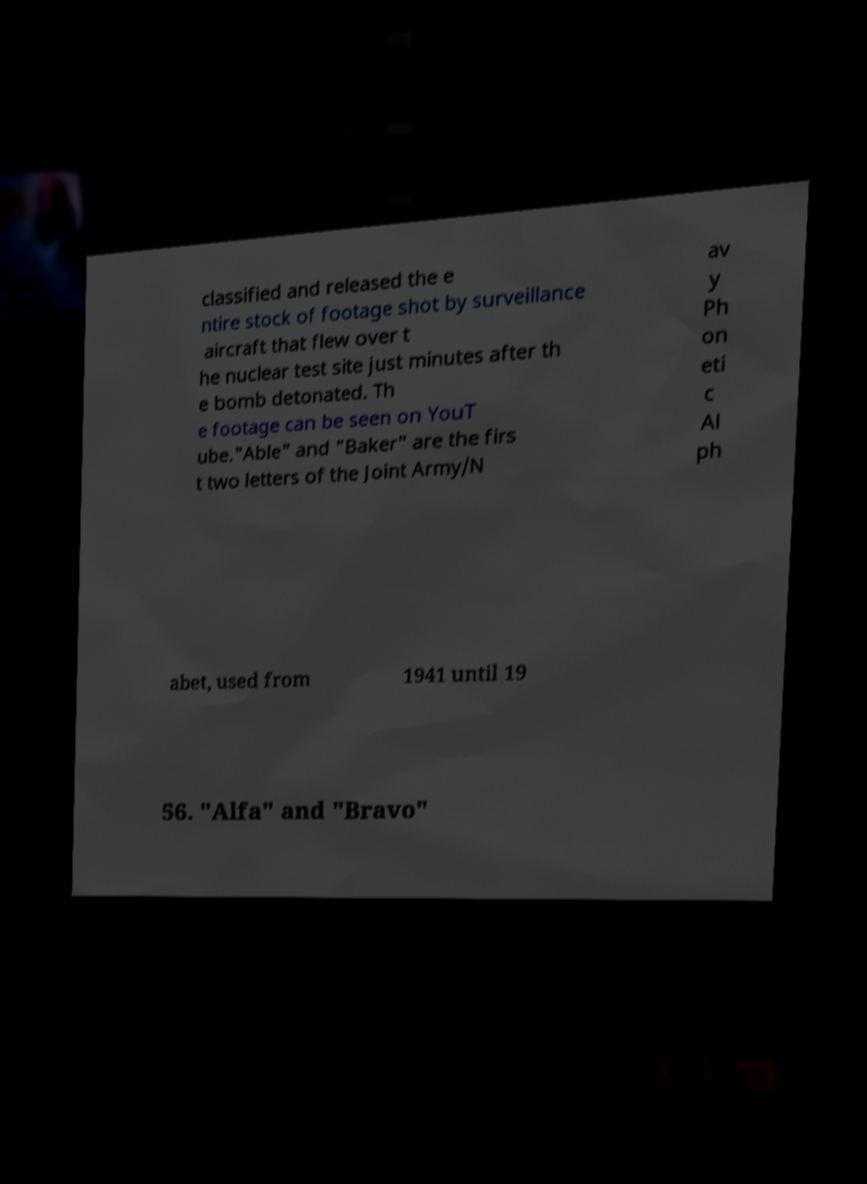What messages or text are displayed in this image? I need them in a readable, typed format. classified and released the e ntire stock of footage shot by surveillance aircraft that flew over t he nuclear test site just minutes after th e bomb detonated. Th e footage can be seen on YouT ube."Able" and "Baker" are the firs t two letters of the Joint Army/N av y Ph on eti c Al ph abet, used from 1941 until 19 56. "Alfa" and "Bravo" 